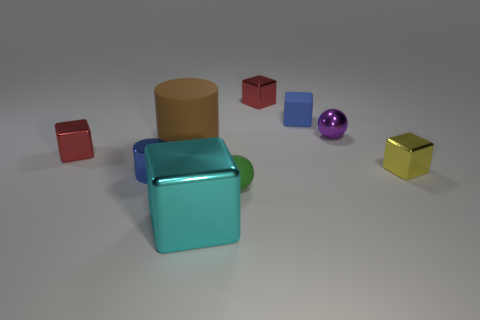Subtract all small blue cubes. How many cubes are left? 4 Subtract all yellow cubes. How many cubes are left? 4 Subtract all brown cubes. Subtract all purple balls. How many cubes are left? 5 Add 1 small blue rubber blocks. How many objects exist? 10 Subtract all blocks. How many objects are left? 4 Add 4 tiny yellow metal objects. How many tiny yellow metal objects exist? 5 Subtract 0 red spheres. How many objects are left? 9 Subtract all big cyan metallic objects. Subtract all green things. How many objects are left? 7 Add 5 yellow metal blocks. How many yellow metal blocks are left? 6 